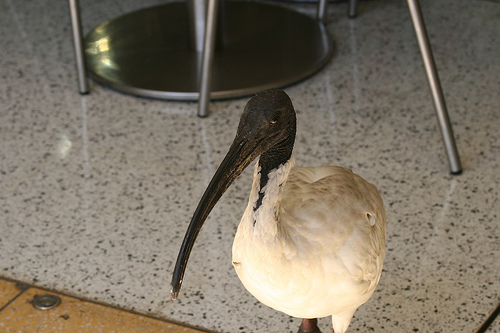Which item of furniture is this?
Answer the question using a single word or phrase. Chair Do the feathers look white? Yes 